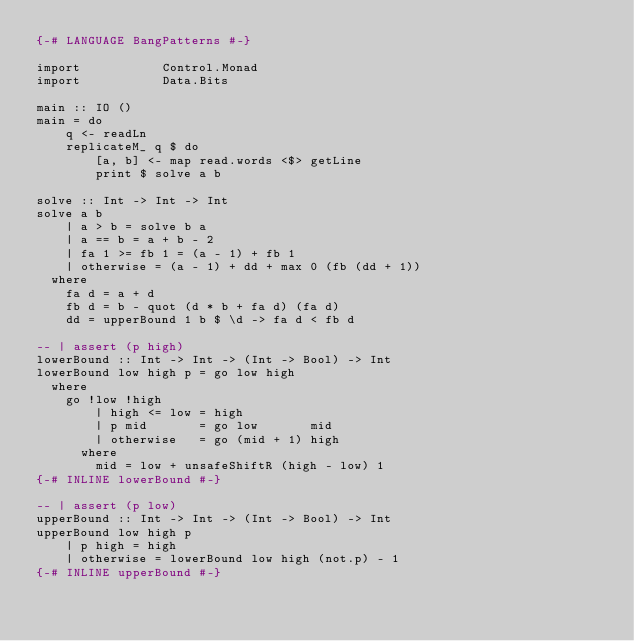Convert code to text. <code><loc_0><loc_0><loc_500><loc_500><_Haskell_>{-# LANGUAGE BangPatterns #-}

import           Control.Monad
import           Data.Bits

main :: IO ()
main = do
    q <- readLn
    replicateM_ q $ do
        [a, b] <- map read.words <$> getLine
        print $ solve a b

solve :: Int -> Int -> Int
solve a b
    | a > b = solve b a
    | a == b = a + b - 2
    | fa 1 >= fb 1 = (a - 1) + fb 1
    | otherwise = (a - 1) + dd + max 0 (fb (dd + 1))
  where
    fa d = a + d
    fb d = b - quot (d * b + fa d) (fa d)
    dd = upperBound 1 b $ \d -> fa d < fb d

-- | assert (p high)
lowerBound :: Int -> Int -> (Int -> Bool) -> Int
lowerBound low high p = go low high
  where
    go !low !high
        | high <= low = high
        | p mid       = go low       mid
        | otherwise   = go (mid + 1) high
      where
        mid = low + unsafeShiftR (high - low) 1
{-# INLINE lowerBound #-}

-- | assert (p low)
upperBound :: Int -> Int -> (Int -> Bool) -> Int
upperBound low high p
    | p high = high
    | otherwise = lowerBound low high (not.p) - 1
{-# INLINE upperBound #-}
</code> 